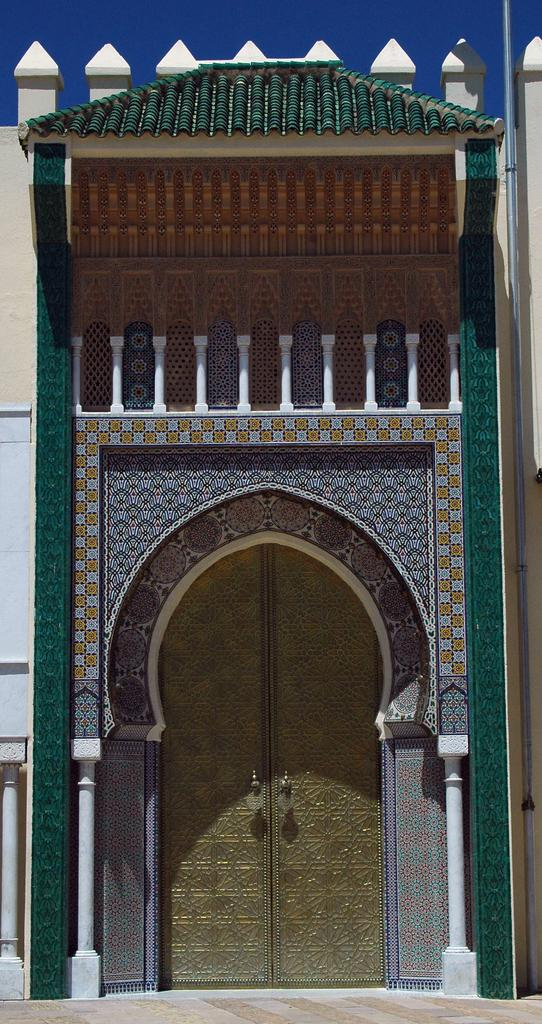What part of a building is shown in the image? The image shows the front of a building. What architectural features can be seen on the front of the building? There are doors, pillars, and an arch in the image. Are there any additional decorative elements on the building? Yes, there are small pillars on top of the building. What can be seen in the background of the image? The sky is visible in the background of the image. What type of weight can be seen on the selection of pillars in the image? There is no weight visible on the pillars in the image, as they are architectural elements and not objects that can hold or support weights. 